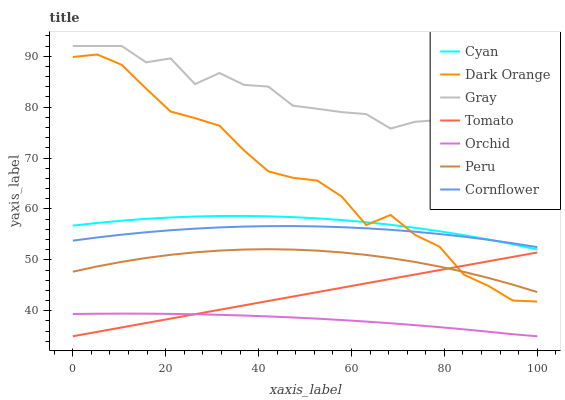Does Orchid have the minimum area under the curve?
Answer yes or no. Yes. Does Gray have the maximum area under the curve?
Answer yes or no. Yes. Does Dark Orange have the minimum area under the curve?
Answer yes or no. No. Does Dark Orange have the maximum area under the curve?
Answer yes or no. No. Is Tomato the smoothest?
Answer yes or no. Yes. Is Gray the roughest?
Answer yes or no. Yes. Is Dark Orange the smoothest?
Answer yes or no. No. Is Dark Orange the roughest?
Answer yes or no. No. Does Tomato have the lowest value?
Answer yes or no. Yes. Does Dark Orange have the lowest value?
Answer yes or no. No. Does Gray have the highest value?
Answer yes or no. Yes. Does Dark Orange have the highest value?
Answer yes or no. No. Is Cyan less than Gray?
Answer yes or no. Yes. Is Gray greater than Cyan?
Answer yes or no. Yes. Does Dark Orange intersect Cyan?
Answer yes or no. Yes. Is Dark Orange less than Cyan?
Answer yes or no. No. Is Dark Orange greater than Cyan?
Answer yes or no. No. Does Cyan intersect Gray?
Answer yes or no. No. 